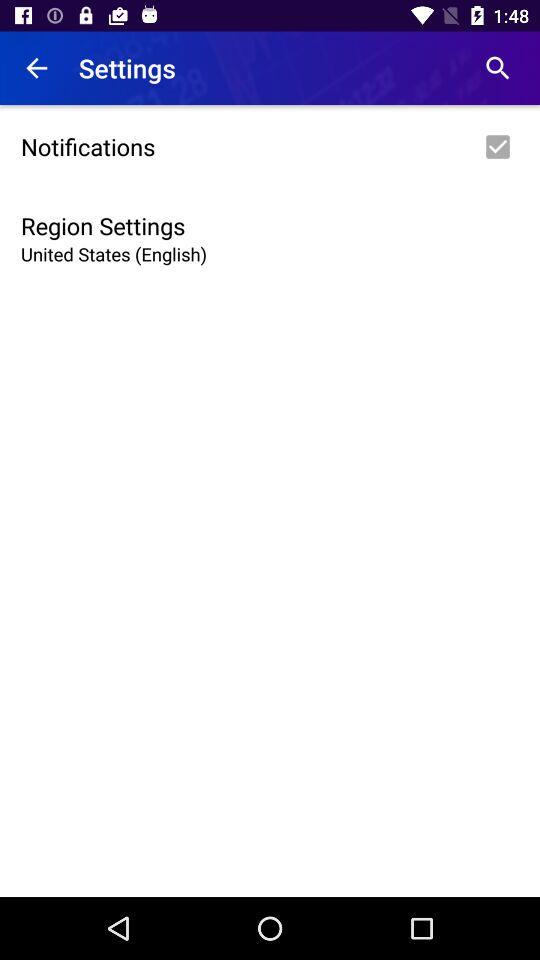What is the current status of the "Notifications" setting? The current status of the "Notifications" setting is "on". 